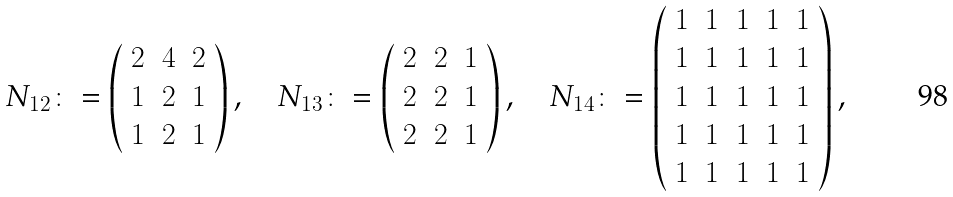<formula> <loc_0><loc_0><loc_500><loc_500>N _ { 1 2 } \colon = \left ( \begin{array} { c c c } 2 & 4 & 2 \\ 1 & 2 & 1 \\ 1 & 2 & 1 \end{array} \right ) , \quad N _ { 1 3 } \colon = \left ( \begin{array} { c c c } 2 & 2 & 1 \\ 2 & 2 & 1 \\ 2 & 2 & 1 \end{array} \right ) , \quad N _ { 1 4 } \colon = \left ( \begin{array} { c c c c c } 1 & 1 & 1 & 1 & 1 \\ 1 & 1 & 1 & 1 & 1 \\ 1 & 1 & 1 & 1 & 1 \\ 1 & 1 & 1 & 1 & 1 \\ 1 & 1 & 1 & 1 & 1 \end{array} \right ) ,</formula> 